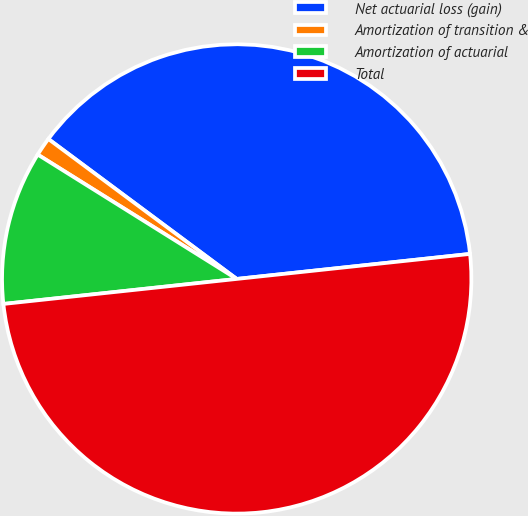Convert chart. <chart><loc_0><loc_0><loc_500><loc_500><pie_chart><fcel>Net actuarial loss (gain)<fcel>Amortization of transition &<fcel>Amortization of actuarial<fcel>Total<nl><fcel>38.13%<fcel>1.28%<fcel>10.59%<fcel>50.0%<nl></chart> 